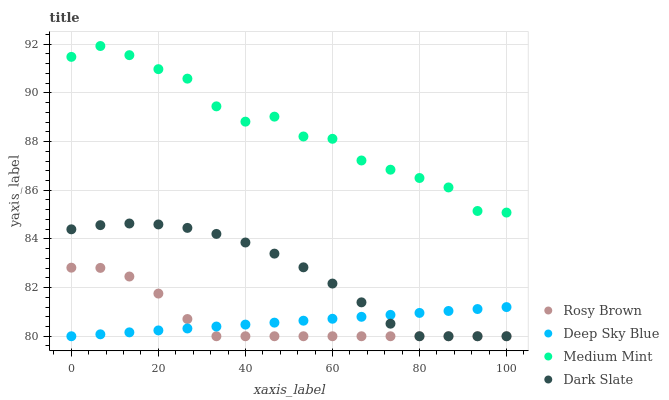Does Deep Sky Blue have the minimum area under the curve?
Answer yes or no. Yes. Does Medium Mint have the maximum area under the curve?
Answer yes or no. Yes. Does Dark Slate have the minimum area under the curve?
Answer yes or no. No. Does Dark Slate have the maximum area under the curve?
Answer yes or no. No. Is Deep Sky Blue the smoothest?
Answer yes or no. Yes. Is Medium Mint the roughest?
Answer yes or no. Yes. Is Dark Slate the smoothest?
Answer yes or no. No. Is Dark Slate the roughest?
Answer yes or no. No. Does Dark Slate have the lowest value?
Answer yes or no. Yes. Does Medium Mint have the highest value?
Answer yes or no. Yes. Does Dark Slate have the highest value?
Answer yes or no. No. Is Deep Sky Blue less than Medium Mint?
Answer yes or no. Yes. Is Medium Mint greater than Deep Sky Blue?
Answer yes or no. Yes. Does Deep Sky Blue intersect Dark Slate?
Answer yes or no. Yes. Is Deep Sky Blue less than Dark Slate?
Answer yes or no. No. Is Deep Sky Blue greater than Dark Slate?
Answer yes or no. No. Does Deep Sky Blue intersect Medium Mint?
Answer yes or no. No. 